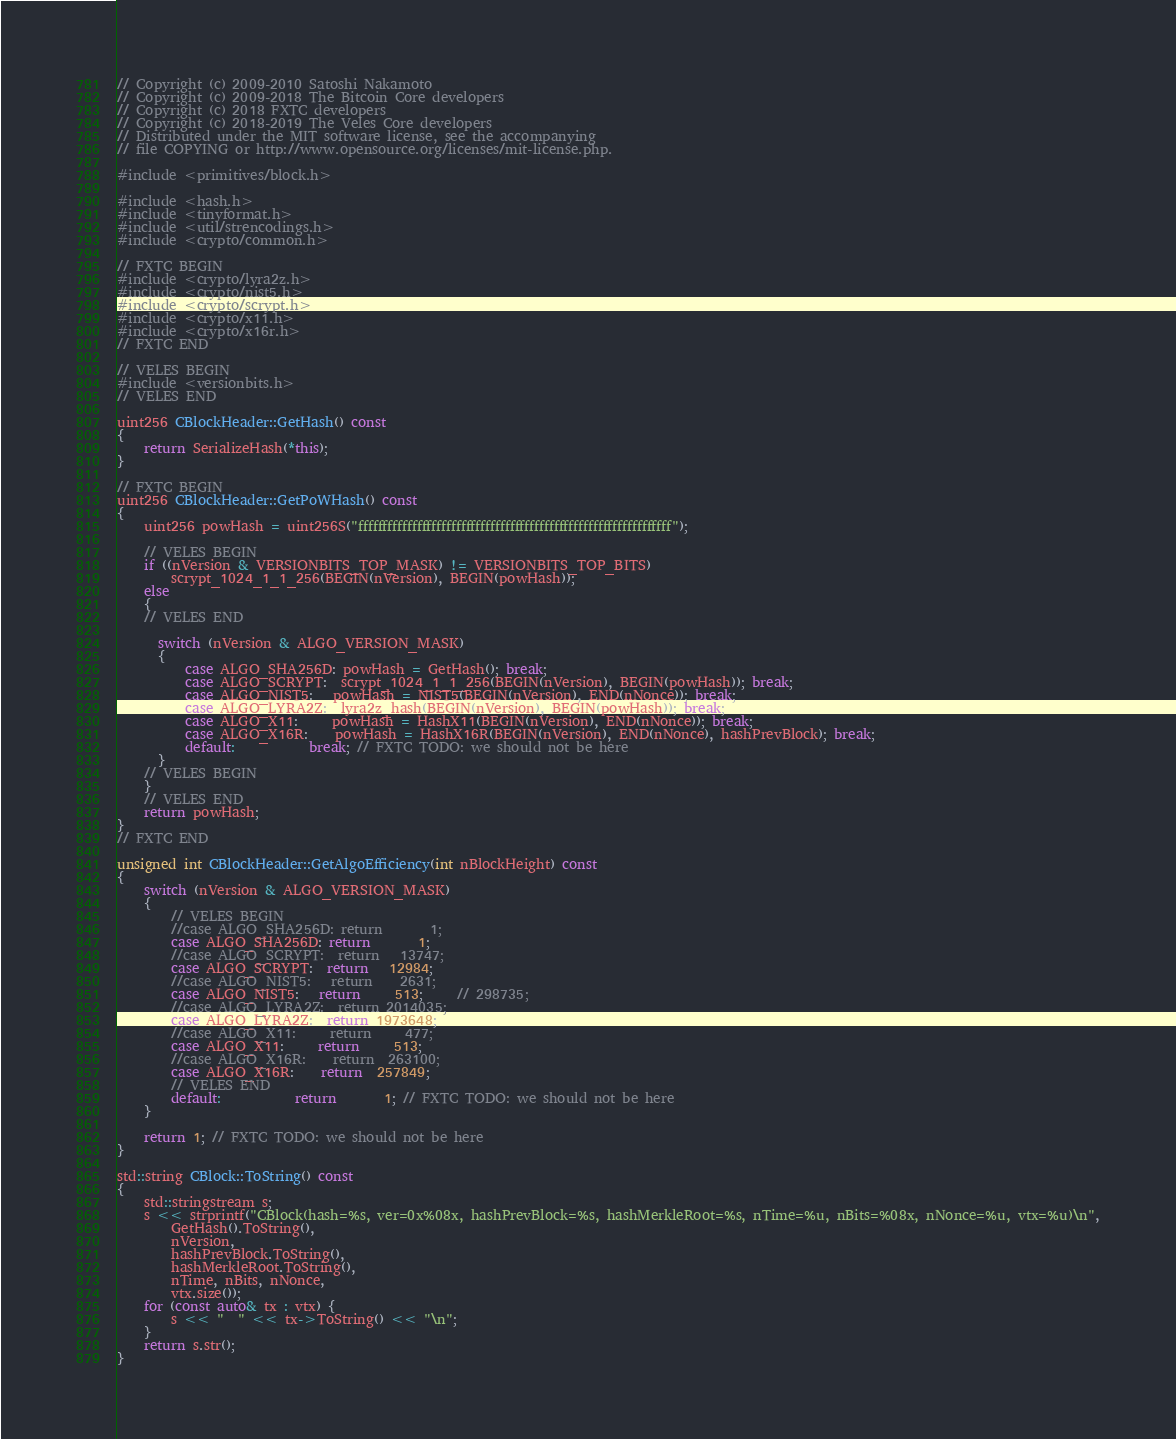Convert code to text. <code><loc_0><loc_0><loc_500><loc_500><_C++_>// Copyright (c) 2009-2010 Satoshi Nakamoto
// Copyright (c) 2009-2018 The Bitcoin Core developers
// Copyright (c) 2018 FXTC developers
// Copyright (c) 2018-2019 The Veles Core developers
// Distributed under the MIT software license, see the accompanying
// file COPYING or http://www.opensource.org/licenses/mit-license.php.

#include <primitives/block.h>

#include <hash.h>
#include <tinyformat.h>
#include <util/strencodings.h>
#include <crypto/common.h>

// FXTC BEGIN
#include <crypto/lyra2z.h>
#include <crypto/nist5.h>
#include <crypto/scrypt.h>
#include <crypto/x11.h>
#include <crypto/x16r.h>
// FXTC END

// VELES BEGIN
#include <versionbits.h>
// VELES END

uint256 CBlockHeader::GetHash() const
{
    return SerializeHash(*this);
}

// FXTC BEGIN
uint256 CBlockHeader::GetPoWHash() const
{
    uint256 powHash = uint256S("ffffffffffffffffffffffffffffffffffffffffffffffffffffffffffffffff");

    // VELES BEGIN
    if ((nVersion & VERSIONBITS_TOP_MASK) != VERSIONBITS_TOP_BITS)
        scrypt_1024_1_1_256(BEGIN(nVersion), BEGIN(powHash));
    else
    {
    // VELES END

      switch (nVersion & ALGO_VERSION_MASK)
      {
          case ALGO_SHA256D: powHash = GetHash(); break;
          case ALGO_SCRYPT:  scrypt_1024_1_1_256(BEGIN(nVersion), BEGIN(powHash)); break;
          case ALGO_NIST5:   powHash = NIST5(BEGIN(nVersion), END(nNonce)); break;
          case ALGO_LYRA2Z:  lyra2z_hash(BEGIN(nVersion), BEGIN(powHash)); break;
          case ALGO_X11:     powHash = HashX11(BEGIN(nVersion), END(nNonce)); break;
          case ALGO_X16R:    powHash = HashX16R(BEGIN(nVersion), END(nNonce), hashPrevBlock); break;
          default:           break; // FXTC TODO: we should not be here
      }
    // VELES BEGIN
    }
    // VELES END
    return powHash;
}
// FXTC END

unsigned int CBlockHeader::GetAlgoEfficiency(int nBlockHeight) const
{
    switch (nVersion & ALGO_VERSION_MASK)
    {
        // VELES BEGIN
        //case ALGO_SHA256D: return       1;
        case ALGO_SHA256D: return       1;
        //case ALGO_SCRYPT:  return   13747;
        case ALGO_SCRYPT:  return   12984;
        //case ALGO_NIST5:   return    2631;
        case ALGO_NIST5:   return     513;     // 298735;
        //case ALGO_LYRA2Z:  return 2014035;
        case ALGO_LYRA2Z:  return 1973648;
        //case ALGO_X11:     return     477;
        case ALGO_X11:     return     513;
        //case ALGO_X16R:    return  263100;
        case ALGO_X16R:    return  257849;
        // VELES END
        default:           return       1; // FXTC TODO: we should not be here
    }

    return 1; // FXTC TODO: we should not be here
}

std::string CBlock::ToString() const
{
    std::stringstream s;
    s << strprintf("CBlock(hash=%s, ver=0x%08x, hashPrevBlock=%s, hashMerkleRoot=%s, nTime=%u, nBits=%08x, nNonce=%u, vtx=%u)\n",
        GetHash().ToString(),
        nVersion,
        hashPrevBlock.ToString(),
        hashMerkleRoot.ToString(),
        nTime, nBits, nNonce,
        vtx.size());
    for (const auto& tx : vtx) {
        s << "  " << tx->ToString() << "\n";
    }
    return s.str();
}
</code> 